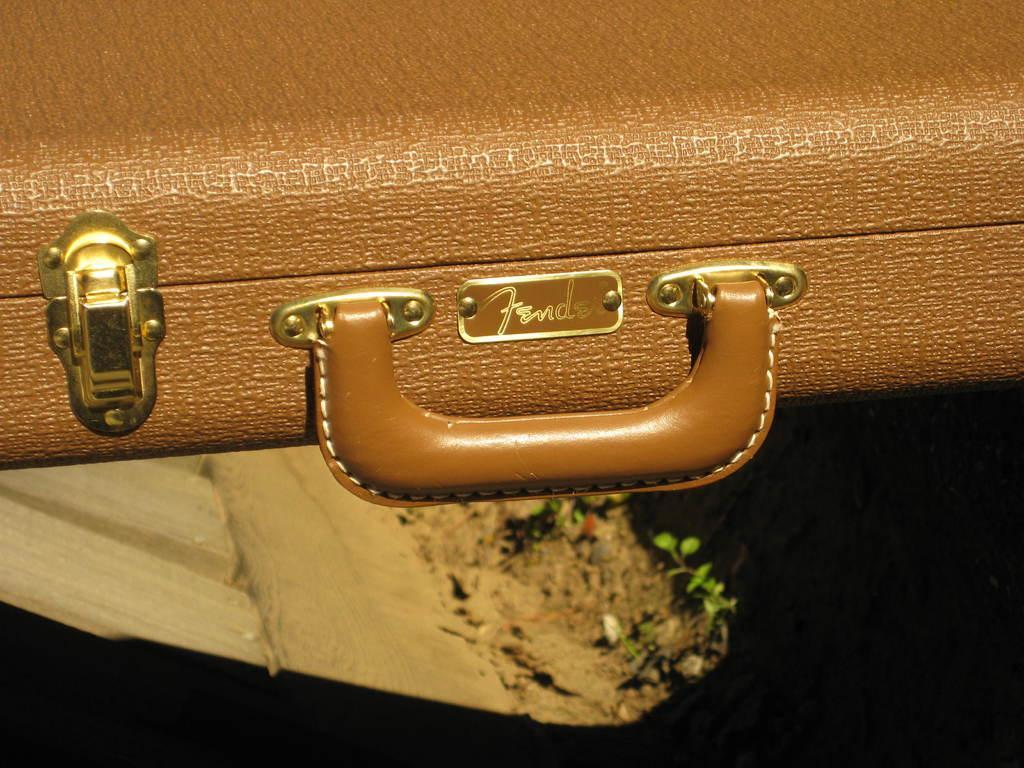Can you describe this image briefly? A suitcase is shown in the picture. It has brown leather covering on it. There is a handle with same color. There is a small name plate. There are locks with golden color. 